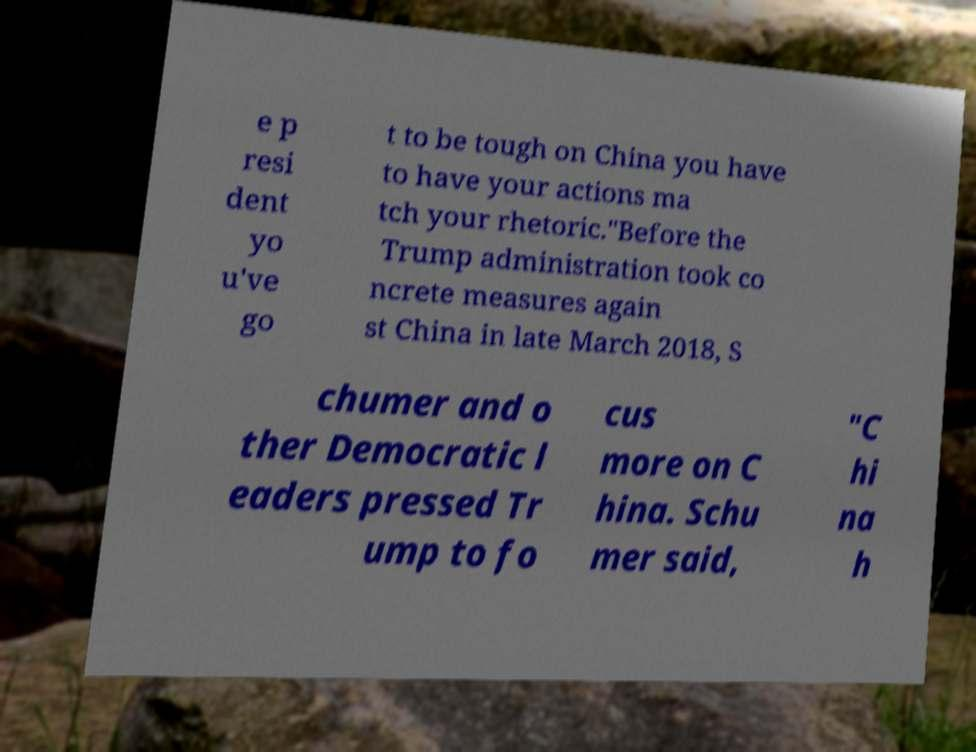Please identify and transcribe the text found in this image. e p resi dent yo u've go t to be tough on China you have to have your actions ma tch your rhetoric."Before the Trump administration took co ncrete measures again st China in late March 2018, S chumer and o ther Democratic l eaders pressed Tr ump to fo cus more on C hina. Schu mer said, "C hi na h 